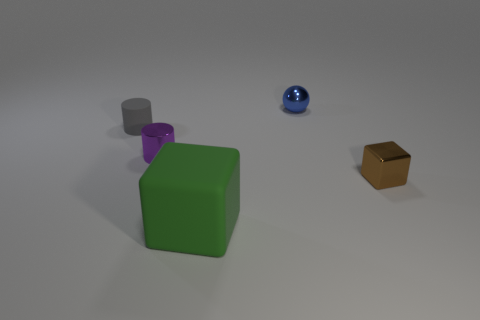Add 4 large green blocks. How many objects exist? 9 Subtract all blocks. How many objects are left? 3 Add 2 small gray cylinders. How many small gray cylinders are left? 3 Add 3 brown metal cubes. How many brown metal cubes exist? 4 Subtract 0 yellow blocks. How many objects are left? 5 Subtract all small brown blocks. Subtract all gray cylinders. How many objects are left? 3 